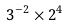<formula> <loc_0><loc_0><loc_500><loc_500>3 ^ { - 2 } \times 2 ^ { 4 }</formula> 